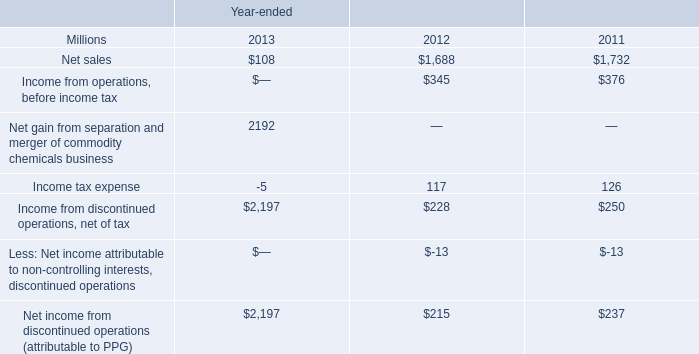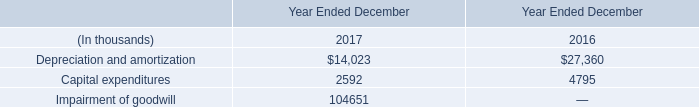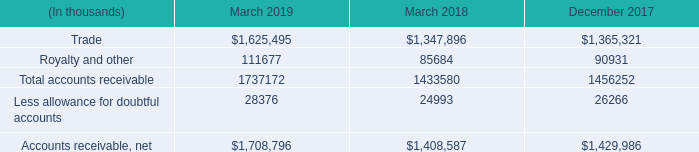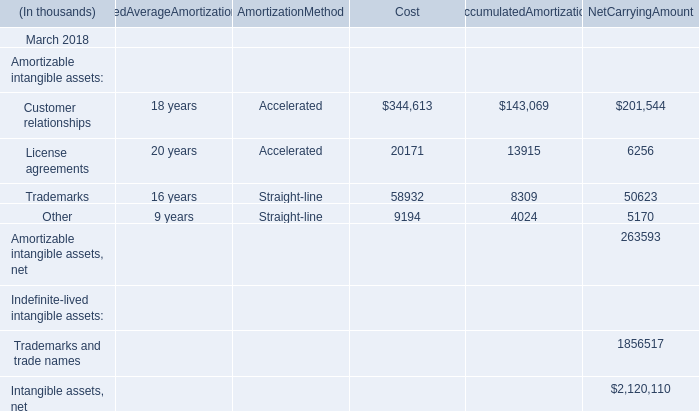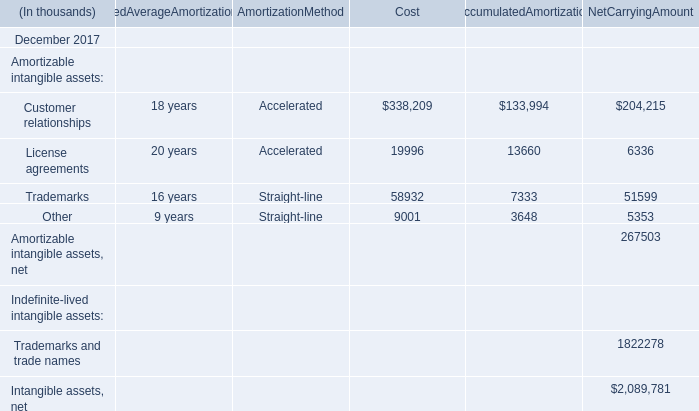What was the total amount of the AccumulatedAmortization in the sections where Cost greater than 0? (in thousand) 
Computations: (((143069 + 13915) + 8309) + 4024)
Answer: 169317.0. 